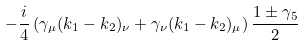<formula> <loc_0><loc_0><loc_500><loc_500>- \frac { i } { 4 } \left ( \gamma _ { \mu } ( k _ { 1 } - k _ { 2 } ) _ { \nu } + \gamma _ { \nu } ( k _ { 1 } - k _ { 2 } ) _ { \mu } \right ) \frac { 1 \pm \gamma _ { 5 } } { 2 }</formula> 